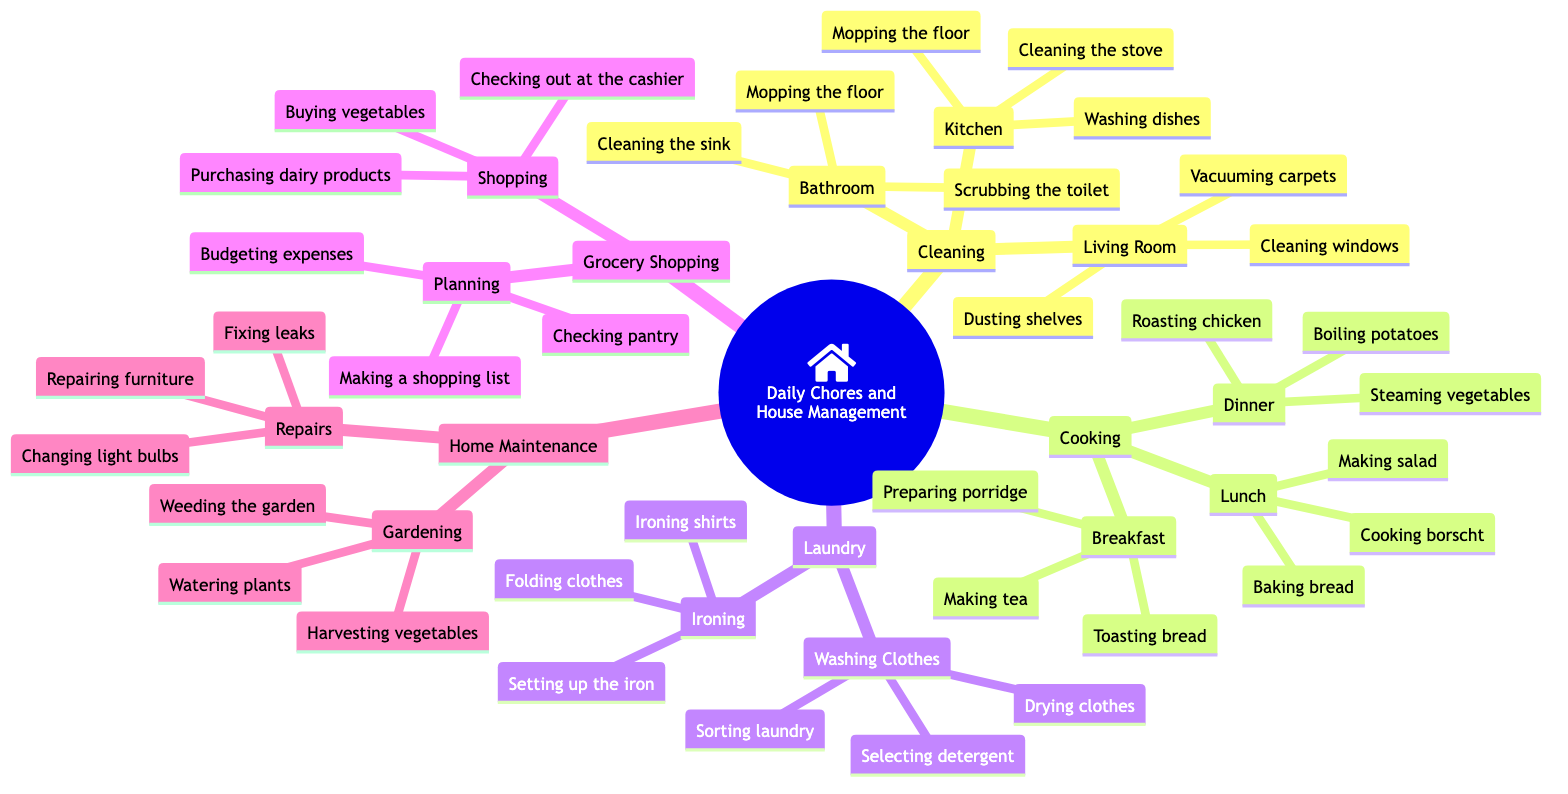What are the main categories of daily chores? The diagram shows five main categories branching from the root: Cleaning, Cooking, Laundry, Grocery Shopping, and Home Maintenance.
Answer: Cleaning, Cooking, Laundry, Grocery Shopping, Home Maintenance How many activities are listed under Cooking? There are three meal times under Cooking: Breakfast, Lunch, and Dinner. Each meal time has three associated activities, totaling nine activities (3 + 3 + 3 = 9).
Answer: 9 What is one task listed under Bathroom cleaning? The diagram shows three tasks under Bathroom: Scrubbing the toilet, Cleaning the sink, and Mopping the floor. Any of these tasks can be mentioned as a correct answer.
Answer: Scrubbing the toilet Which chore has a subcategory that includes repairing furniture? Home Maintenance has a subcategory labeled "Repairs," which includes the task of repairing furniture along with fixing leaks and changing light bulbs.
Answer: Repairs What is the first step in Grocery Shopping planning? The first step listed under Planning in Grocery Shopping is Making a shopping list, followed by Checking pantry and Budgeting expenses.
Answer: Making a shopping list How many tasks are related to laundry? Under Laundry, there are two subcategories: Washing Clothes and Ironing. Washing Clothes has three tasks, and Ironing has three tasks, resulting in a total of six tasks (3 + 3 = 6).
Answer: 6 What activity is associated with gardening? Gardening is a subcategory under Home Maintenance that includes tasks such as Watering plants, Weeding the garden, and Harvesting vegetables. Any of these tasks can be mentioned as an answer.
Answer: Watering plants What is included in the process of cooking lunch? Lunch has three associated activities: Cooking borscht, Making salad, and Baking bread. Any of these tasks could be a valid answer.
Answer: Cooking borscht Which task involves sorting laundry? Sorting laundry is part of the Washing Clothes subcategory under Laundry. It is the first task listed under that section.
Answer: Sorting laundry 